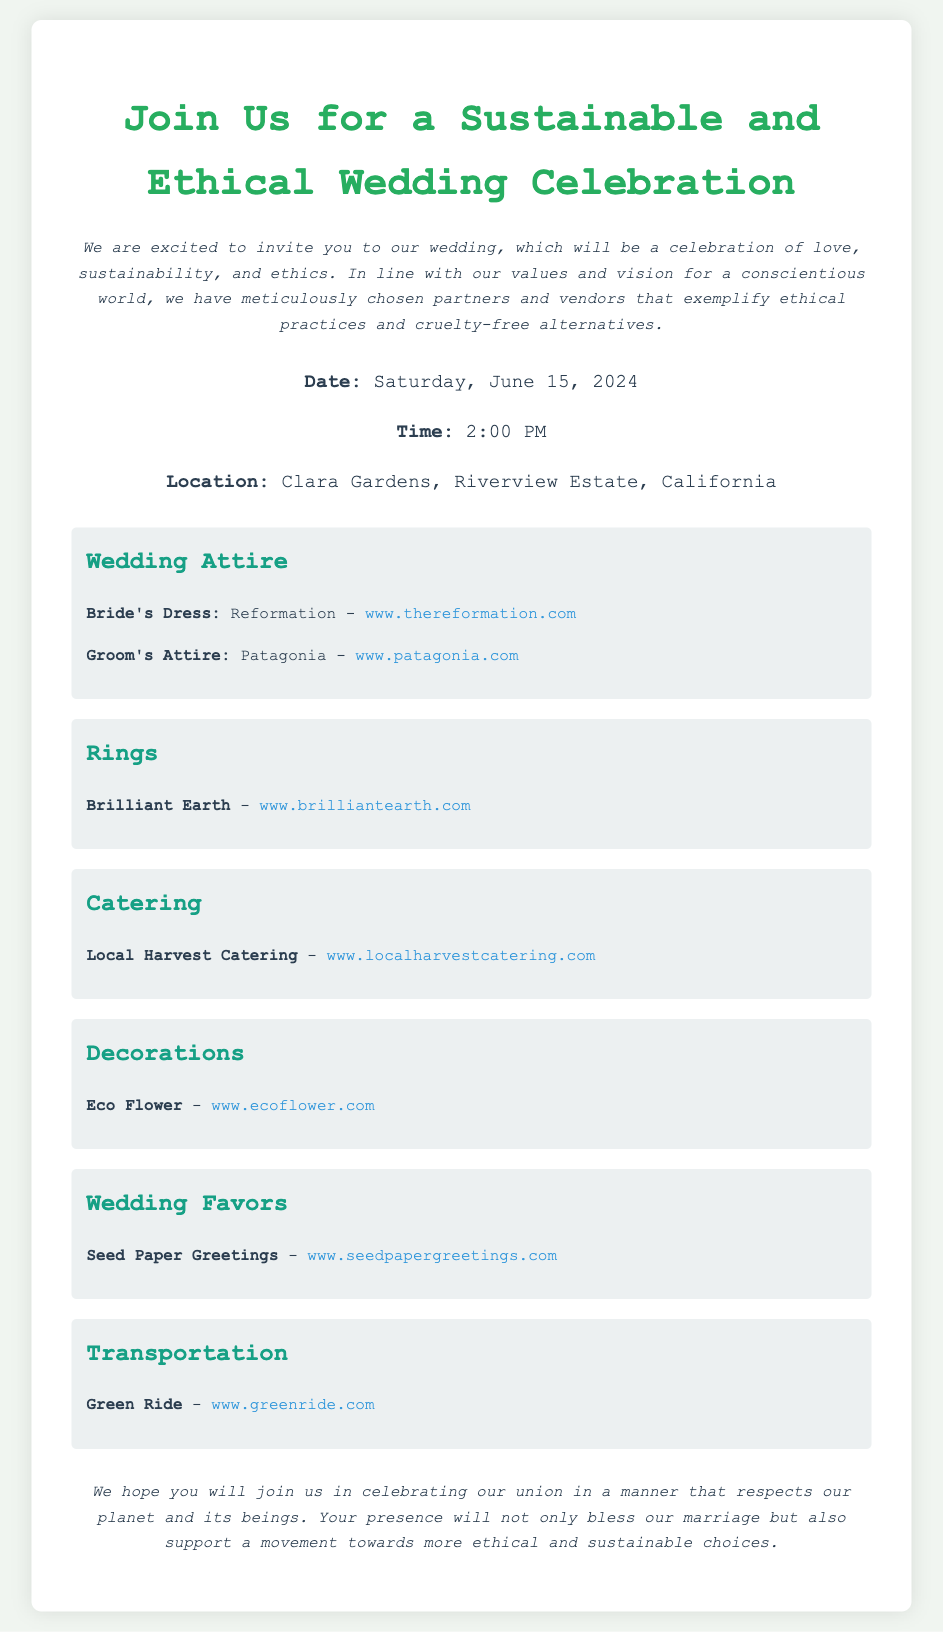what is the date of the wedding? The date of the wedding is explicitly stated in the details section of the document.
Answer: Saturday, June 15, 2024 what is the name of the venue? The venue name is mentioned in the details section.
Answer: Clara Gardens, Riverview Estate, California who is the vendor for the bride's dress? The vendor for the bride's dress is identified in the wedding attire section of the document.
Answer: Reformation what type of catering service is being used? The type of catering service is indicated in the catering section of the document.
Answer: Local Harvest Catering which company provides the wedding favors? The vendor for the wedding favors is listed in the wedding favors section.
Answer: Seed Paper Greetings how does the couple view their wedding celebration? The view of the couple towards their wedding celebration is expressed in the introduction of the document.
Answer: a celebration of love, sustainability, and ethics what transportation service is mentioned? The transportation service used for the wedding is provided in the transportation section of the document.
Answer: Green Ride how are the decorations sourced for the wedding? The source of the decorations is found in the decorations section, and it reflects the couple's ethical choice.
Answer: Eco Flower what is the main purpose of this wedding invitation? The main purpose of the invitation is summarized in the closing remarks of the document.
Answer: to celebrate in a manner that respects our planet and its beings 